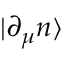Convert formula to latex. <formula><loc_0><loc_0><loc_500><loc_500>| \partial _ { \mu } n \rangle</formula> 